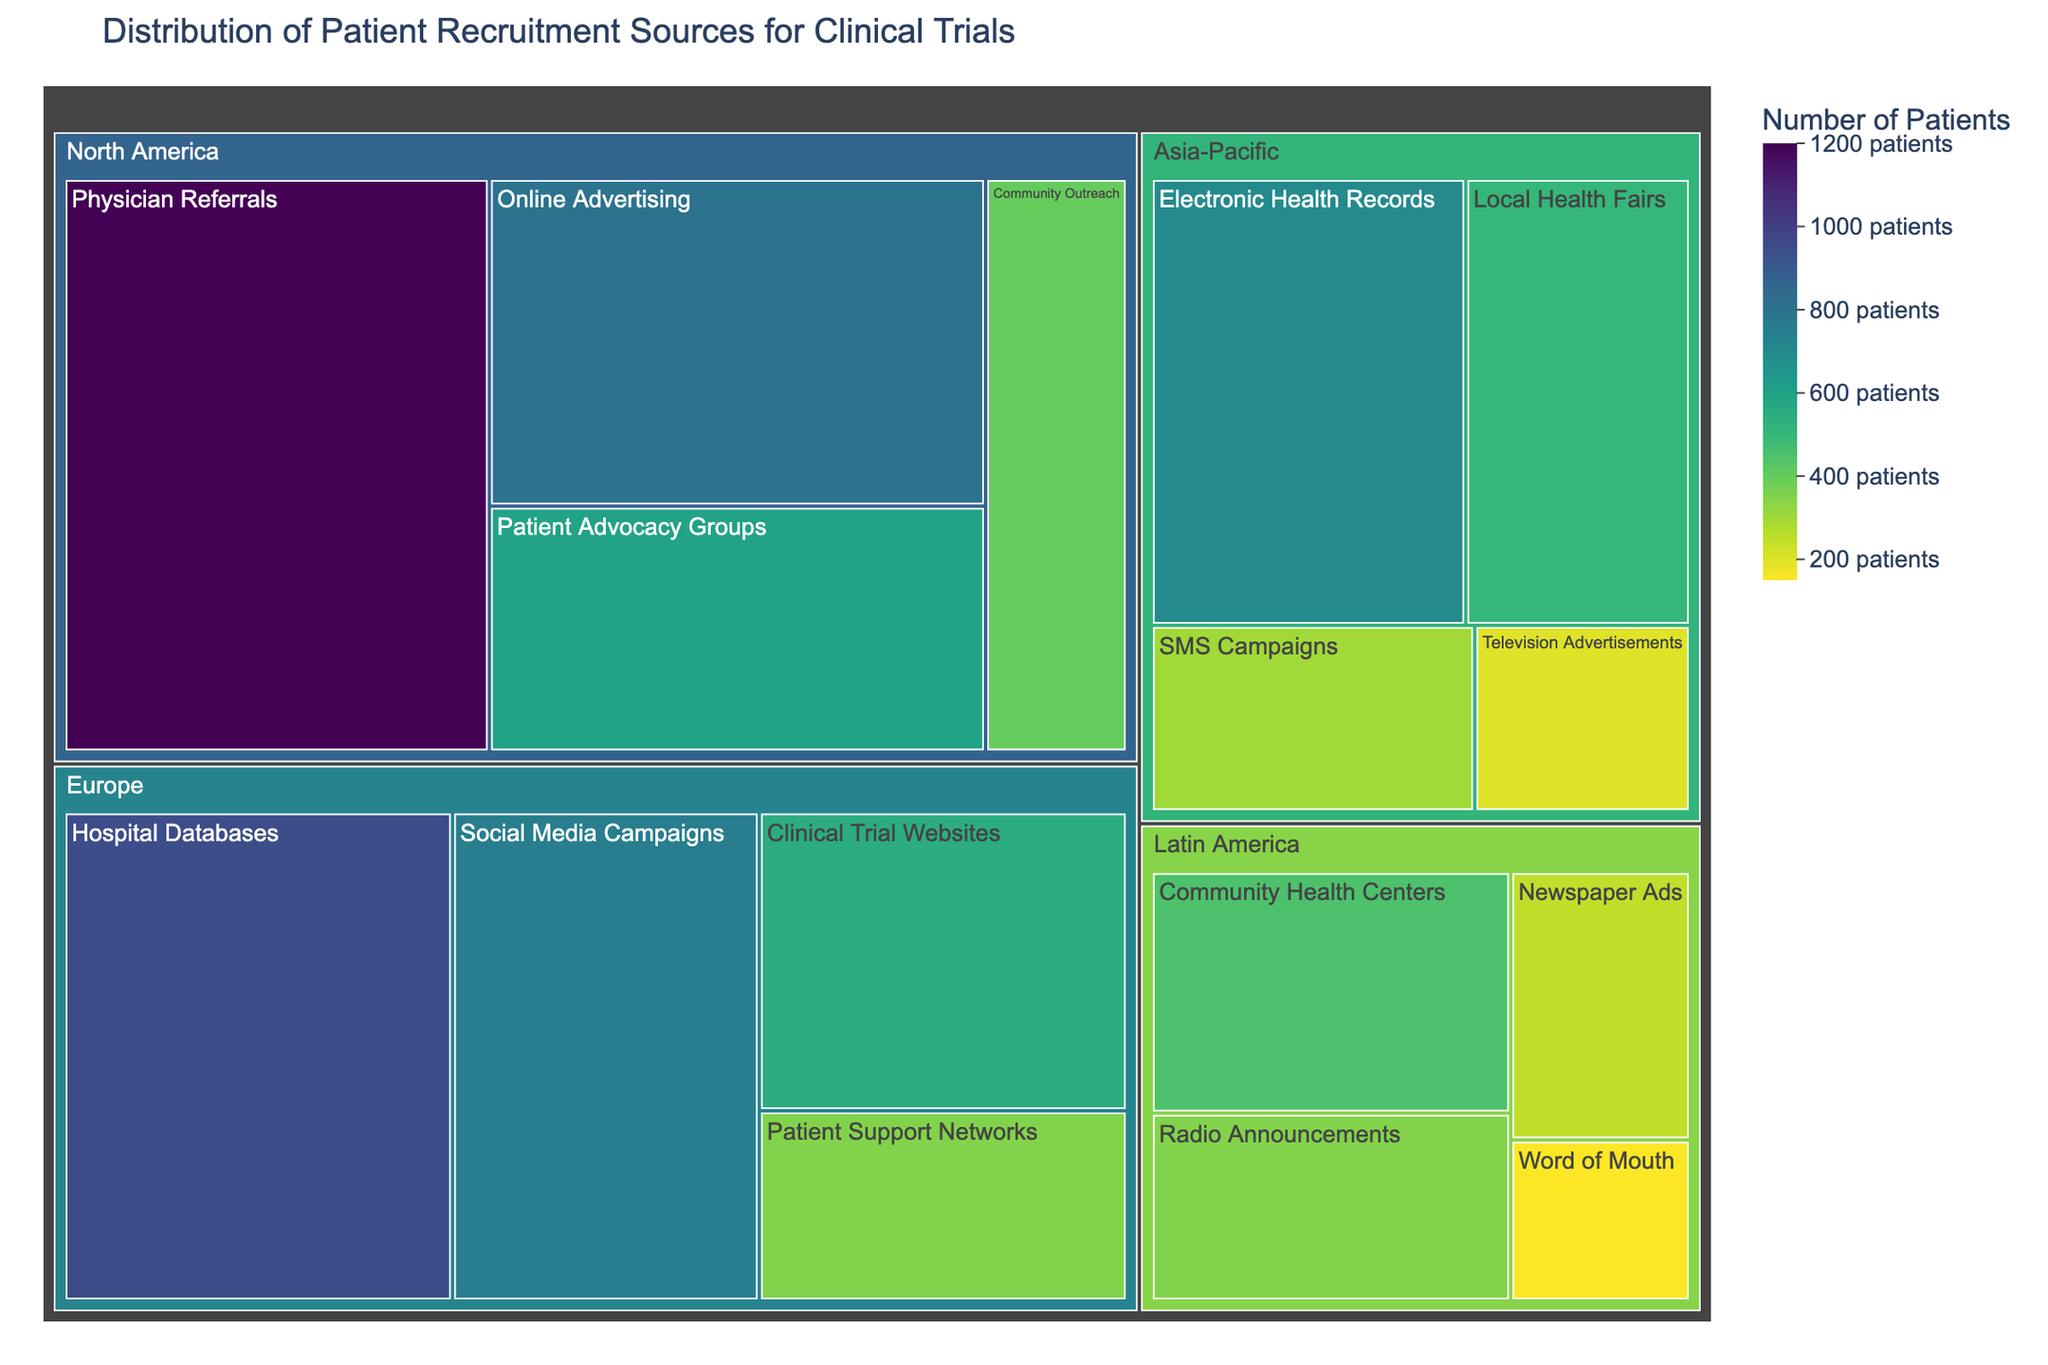what is the title of the figure? The title of a treemap is typically displayed at the top of the figure. By reading it directly, one can determine the descriptive label of the visualized data.
Answer: Distribution of Patient Recruitment Sources for Clinical Trials How many patients were recruited through Community Outreach in North America? To determine this, locate the "Community Outreach" section within the "North America" region on the treemap and refer to the patient count.
Answer: 400 Which recruitment method in Europe recruited the most patients? Within the "Europe" region on the treemap, compare the patient counts for each recruitment method and identify the one with the highest number.
Answer: Hospital Databases Compare the patient recruitment numbers between Europe and Latin America. Which region recruited more patients overall? Sum the patient counts for all recruitment methods in Europe and Latin America. Compare the totals to determine which region recruited more patients.
Answer: Europe What is the least utilized recruitment method in the Asia-Pacific region? By examining the treemap under the "Asia-Pacific" region, identify the recruitment method with the lowest patient count.
Answer: Television Advertisements Which region has the highest variation in patient recruitment numbers among its methods? Calculate the range (difference between the highest and lowest values) of patient recruitment numbers within each region, then compare these ranges to identify the region with the highest variation.
Answer: North America Sum up the number of patients recruited through all the methods in North America and Asia-Pacific. Add together the patient counts from all recruitment methods in North America and all methods in the Asia-Pacific region.
Answer: 4000 Is there any recruitment method where the count of patients is the same in both Europe and Asia-Pacific? Compare each recruitment method's patient counts in both regions to see if there is an exact match.
Answer: No What is the difference in the number of patients recruited through Social Media Campaigns in Europe and SMS Campaigns in Asia-Pacific? Subtract the number of patients recruited through SMS Campaigns in Asia-Pacific from the number recruited through Social Media Campaigns in Europe.
Answer: 450 How does the distribution of recruitment methods in North America contrast with those in Latin America in terms of the number of patients? Describe the relative sizes (patient count) of the various recruitment methods in each region and point out any significant contrasts.
Answer: North America has higher patient counts across all methods compared to Latin America 